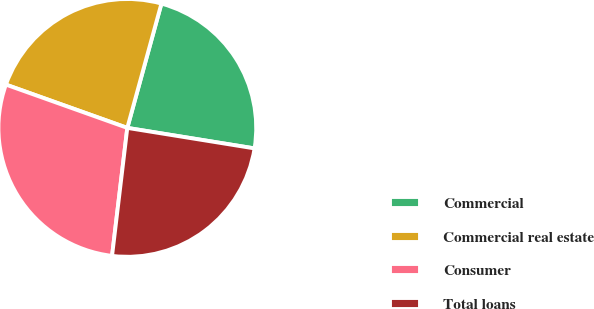Convert chart to OTSL. <chart><loc_0><loc_0><loc_500><loc_500><pie_chart><fcel>Commercial<fcel>Commercial real estate<fcel>Consumer<fcel>Total loans<nl><fcel>23.28%<fcel>23.81%<fcel>28.56%<fcel>24.34%<nl></chart> 